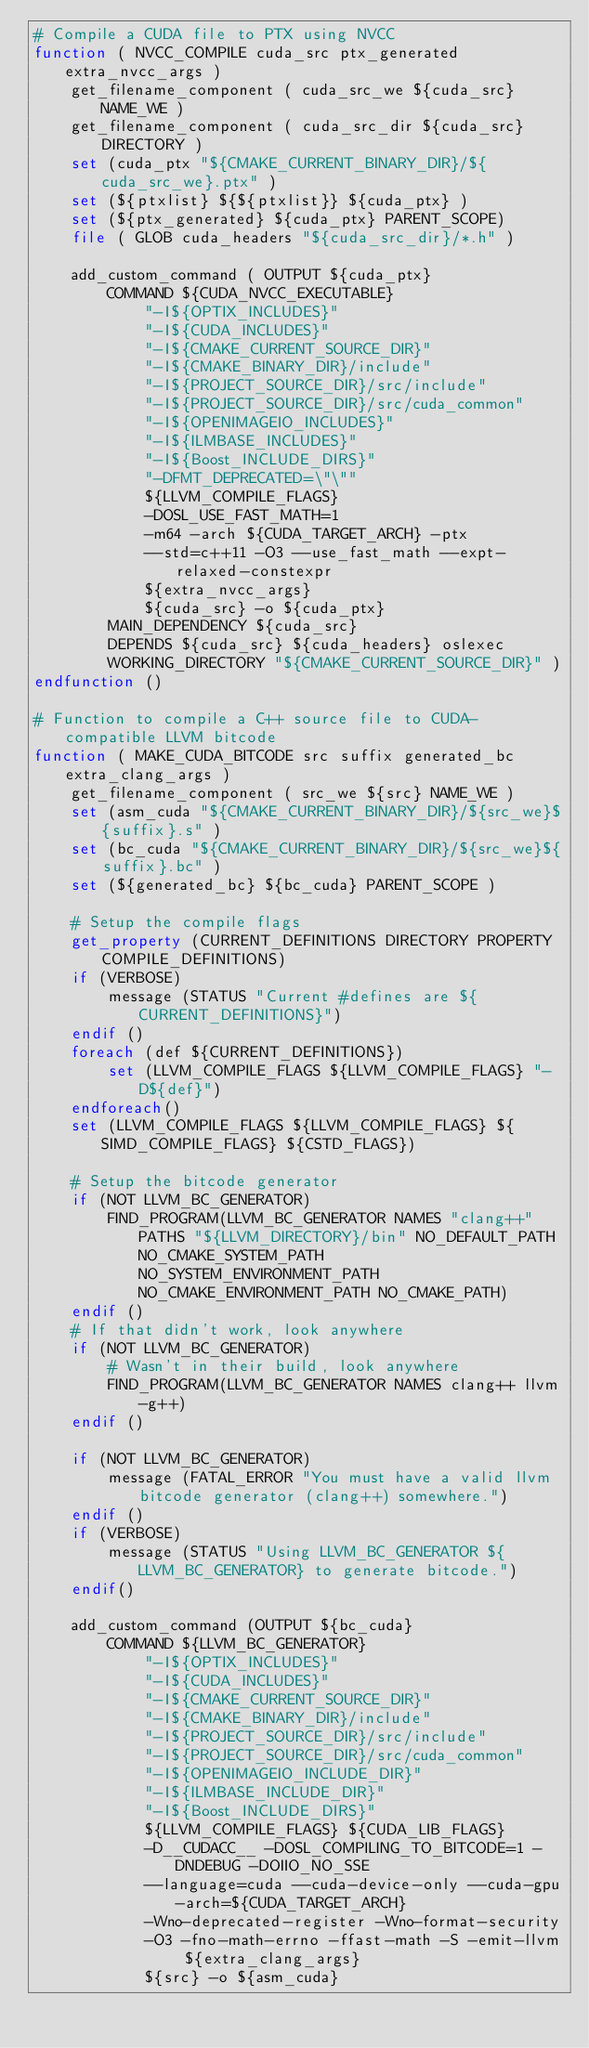<code> <loc_0><loc_0><loc_500><loc_500><_CMake_># Compile a CUDA file to PTX using NVCC
function ( NVCC_COMPILE cuda_src ptx_generated extra_nvcc_args )
    get_filename_component ( cuda_src_we ${cuda_src} NAME_WE )
    get_filename_component ( cuda_src_dir ${cuda_src} DIRECTORY )
    set (cuda_ptx "${CMAKE_CURRENT_BINARY_DIR}/${cuda_src_we}.ptx" )
    set (${ptxlist} ${${ptxlist}} ${cuda_ptx} )
    set (${ptx_generated} ${cuda_ptx} PARENT_SCOPE)
    file ( GLOB cuda_headers "${cuda_src_dir}/*.h" )

    add_custom_command ( OUTPUT ${cuda_ptx}
        COMMAND ${CUDA_NVCC_EXECUTABLE}
            "-I${OPTIX_INCLUDES}"
            "-I${CUDA_INCLUDES}"
            "-I${CMAKE_CURRENT_SOURCE_DIR}"
            "-I${CMAKE_BINARY_DIR}/include"
            "-I${PROJECT_SOURCE_DIR}/src/include"
            "-I${PROJECT_SOURCE_DIR}/src/cuda_common"
            "-I${OPENIMAGEIO_INCLUDES}"
            "-I${ILMBASE_INCLUDES}"
            "-I${Boost_INCLUDE_DIRS}"
            "-DFMT_DEPRECATED=\"\""
            ${LLVM_COMPILE_FLAGS}
            -DOSL_USE_FAST_MATH=1
            -m64 -arch ${CUDA_TARGET_ARCH} -ptx
            --std=c++11 -O3 --use_fast_math --expt-relaxed-constexpr
            ${extra_nvcc_args}
            ${cuda_src} -o ${cuda_ptx}
        MAIN_DEPENDENCY ${cuda_src}
        DEPENDS ${cuda_src} ${cuda_headers} oslexec
        WORKING_DIRECTORY "${CMAKE_CURRENT_SOURCE_DIR}" )
endfunction ()

# Function to compile a C++ source file to CUDA-compatible LLVM bitcode
function ( MAKE_CUDA_BITCODE src suffix generated_bc extra_clang_args )
    get_filename_component ( src_we ${src} NAME_WE )
    set (asm_cuda "${CMAKE_CURRENT_BINARY_DIR}/${src_we}${suffix}.s" )
    set (bc_cuda "${CMAKE_CURRENT_BINARY_DIR}/${src_we}${suffix}.bc" )
    set (${generated_bc} ${bc_cuda} PARENT_SCOPE )

    # Setup the compile flags
    get_property (CURRENT_DEFINITIONS DIRECTORY PROPERTY COMPILE_DEFINITIONS)
    if (VERBOSE)
        message (STATUS "Current #defines are ${CURRENT_DEFINITIONS}")
    endif ()
    foreach (def ${CURRENT_DEFINITIONS})
        set (LLVM_COMPILE_FLAGS ${LLVM_COMPILE_FLAGS} "-D${def}")
    endforeach()
    set (LLVM_COMPILE_FLAGS ${LLVM_COMPILE_FLAGS} ${SIMD_COMPILE_FLAGS} ${CSTD_FLAGS})

    # Setup the bitcode generator
    if (NOT LLVM_BC_GENERATOR)
        FIND_PROGRAM(LLVM_BC_GENERATOR NAMES "clang++" PATHS "${LLVM_DIRECTORY}/bin" NO_DEFAULT_PATH NO_CMAKE_SYSTEM_PATH NO_SYSTEM_ENVIRONMENT_PATH NO_CMAKE_ENVIRONMENT_PATH NO_CMAKE_PATH)
    endif ()
    # If that didn't work, look anywhere
    if (NOT LLVM_BC_GENERATOR)
        # Wasn't in their build, look anywhere
        FIND_PROGRAM(LLVM_BC_GENERATOR NAMES clang++ llvm-g++)
    endif ()

    if (NOT LLVM_BC_GENERATOR)
        message (FATAL_ERROR "You must have a valid llvm bitcode generator (clang++) somewhere.")
    endif ()
    if (VERBOSE)
        message (STATUS "Using LLVM_BC_GENERATOR ${LLVM_BC_GENERATOR} to generate bitcode.")
    endif()

    add_custom_command (OUTPUT ${bc_cuda}
        COMMAND ${LLVM_BC_GENERATOR}
            "-I${OPTIX_INCLUDES}"
            "-I${CUDA_INCLUDES}"
            "-I${CMAKE_CURRENT_SOURCE_DIR}"
            "-I${CMAKE_BINARY_DIR}/include"
            "-I${PROJECT_SOURCE_DIR}/src/include"
            "-I${PROJECT_SOURCE_DIR}/src/cuda_common"
            "-I${OPENIMAGEIO_INCLUDE_DIR}"
            "-I${ILMBASE_INCLUDE_DIR}"
            "-I${Boost_INCLUDE_DIRS}"
            ${LLVM_COMPILE_FLAGS} ${CUDA_LIB_FLAGS}
            -D__CUDACC__ -DOSL_COMPILING_TO_BITCODE=1 -DNDEBUG -DOIIO_NO_SSE
            --language=cuda --cuda-device-only --cuda-gpu-arch=${CUDA_TARGET_ARCH}
            -Wno-deprecated-register -Wno-format-security
            -O3 -fno-math-errno -ffast-math -S -emit-llvm ${extra_clang_args}
            ${src} -o ${asm_cuda}</code> 